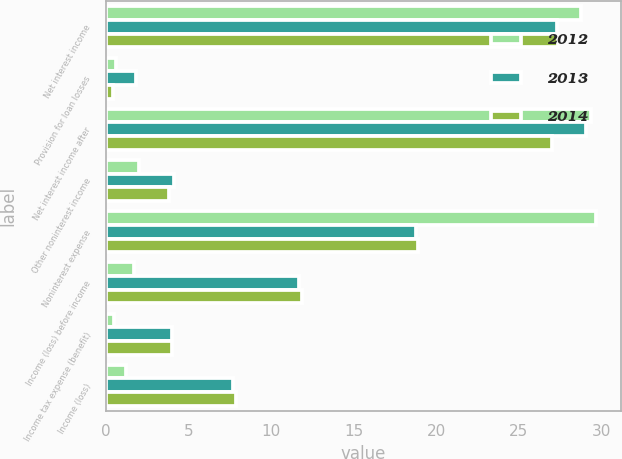<chart> <loc_0><loc_0><loc_500><loc_500><stacked_bar_chart><ecel><fcel>Net interest income<fcel>Provision for loan losses<fcel>Net interest income after<fcel>Other noninterest income<fcel>Noninterest expense<fcel>Income (loss) before income<fcel>Income tax expense (benefit)<fcel>Income (loss)<nl><fcel>2012<fcel>28.8<fcel>0.6<fcel>29.4<fcel>2<fcel>29.7<fcel>1.7<fcel>0.5<fcel>1.2<nl><fcel>2013<fcel>27.3<fcel>1.8<fcel>29.1<fcel>4.1<fcel>18.8<fcel>11.7<fcel>4<fcel>7.7<nl><fcel>2014<fcel>27.4<fcel>0.4<fcel>27<fcel>3.8<fcel>18.9<fcel>11.9<fcel>4<fcel>7.9<nl></chart> 